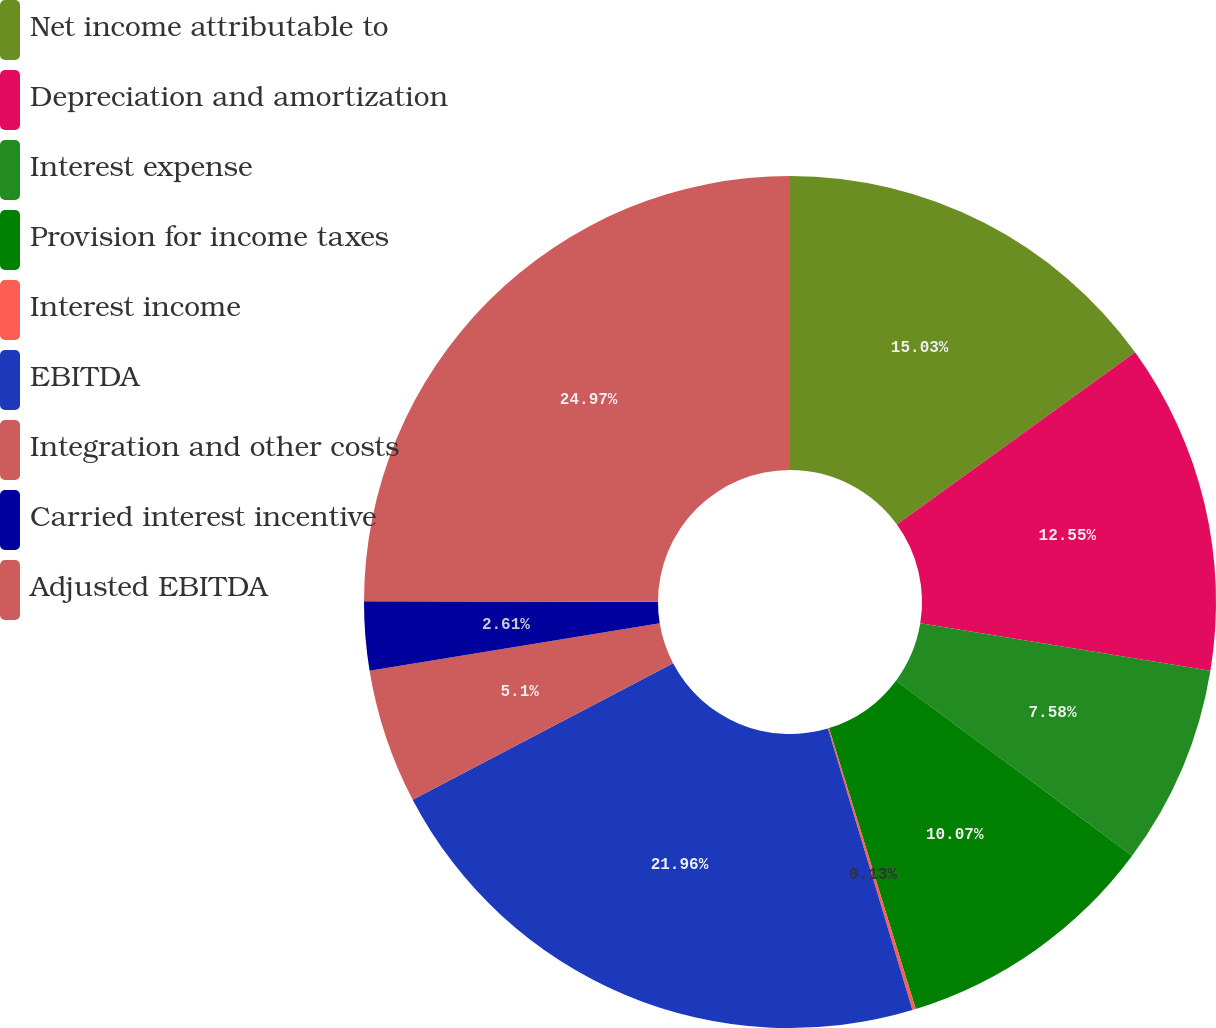Convert chart to OTSL. <chart><loc_0><loc_0><loc_500><loc_500><pie_chart><fcel>Net income attributable to<fcel>Depreciation and amortization<fcel>Interest expense<fcel>Provision for income taxes<fcel>Interest income<fcel>EBITDA<fcel>Integration and other costs<fcel>Carried interest incentive<fcel>Adjusted EBITDA<nl><fcel>15.03%<fcel>12.55%<fcel>7.58%<fcel>10.07%<fcel>0.13%<fcel>21.96%<fcel>5.1%<fcel>2.61%<fcel>24.97%<nl></chart> 